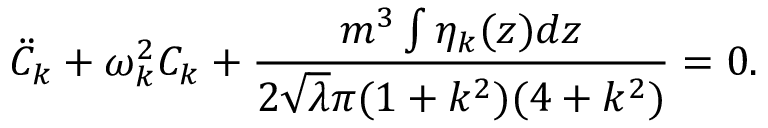<formula> <loc_0><loc_0><loc_500><loc_500>{ \ddot { C } } _ { k } + \omega _ { k } ^ { 2 } C _ { k } + \frac { m ^ { 3 } \int \eta _ { k } ( z ) d z } { 2 { \sqrt { \lambda } } \pi ( 1 + k ^ { 2 } ) ( 4 + k ^ { 2 } ) } = 0 .</formula> 